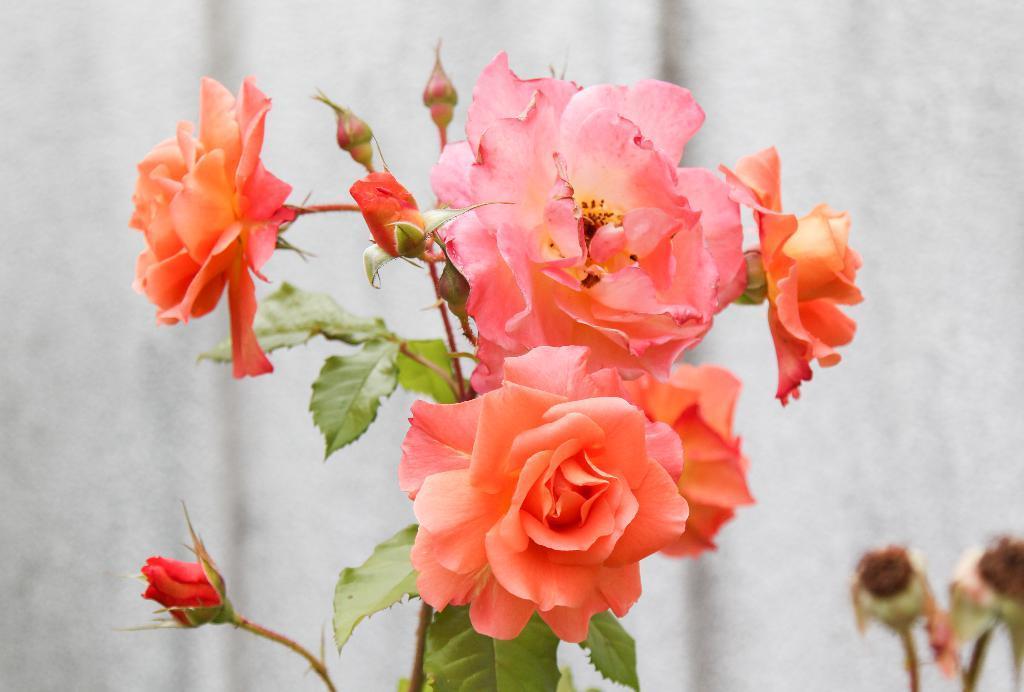Please provide a concise description of this image. In this image, we can see a plant with some flowers and buds. We can also see the background and some objects on the bottom right corner. 